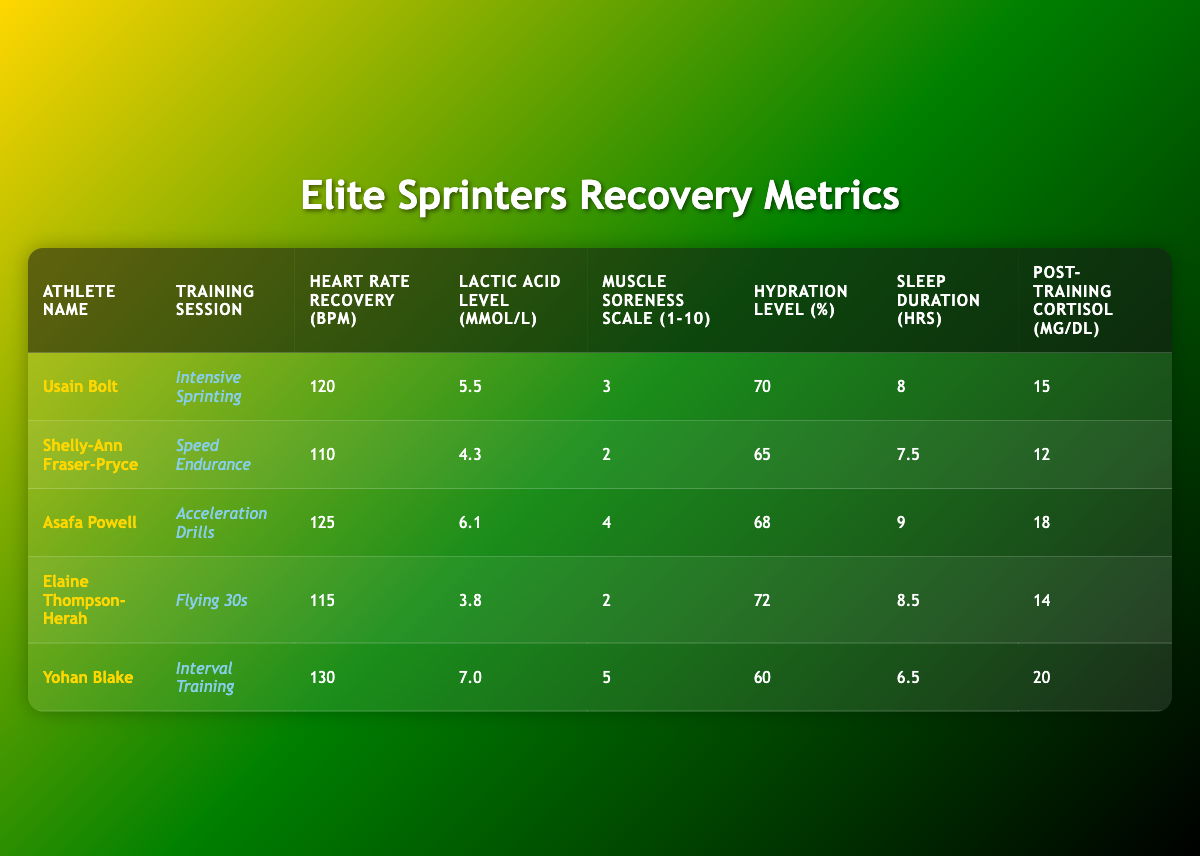What is Usain Bolt's lactic acid level? Usain Bolt's lactic acid level is directly listed in the table under his row. The value is 5.5 mmol/L.
Answer: 5.5 mmol/L What training session did Shelly-Ann Fraser-Pryce participate in? The table lists the training session for each athlete. For Shelly-Ann Fraser-Pryce, the training session is "Speed Endurance."
Answer: Speed Endurance Who has the highest heart rate recovery value? To find the highest heart rate recovery, we must compare the values from each athlete's row. Yohan Blake has the highest heart rate recovery at 130 bpm.
Answer: Yohan Blake What is the average sleep duration of all athletes? The sleep durations are: 8, 7.5, 9, 8.5, and 6.5 hours. Adding these gives a total of 39.5 hours. Dividing by the number of athletes, 5, gives an average of 39.5/5 = 7.9 hours.
Answer: 7.9 hours Did Elaine Thompson-Herah have a hydration level above 70%? Looking at Elaine Thompson-Herah's row, her hydration level is 72%. Since 72 is greater than 70, the answer is yes.
Answer: Yes What is the difference between the highest and lowest muscle soreness scale? The highest muscle soreness scale is 5 (Yohan Blake), and the lowest is 2 (Shelly-Ann Fraser-Pryce and Elaine Thompson-Herah). The difference is 5 - 2 = 3.
Answer: 3 Which athlete had the lowest post-training cortisol level? By checking the post-training cortisol values for each athlete, Shelly-Ann Fraser-Pryce has the lowest at 12 μg/dL compared to others.
Answer: Shelly-Ann Fraser-Pryce Which athlete trained with the "Interval Training" session? The athlete who participated in "Interval Training" is clearly listed in the table as Yohan Blake.
Answer: Yohan Blake What percentage of hydration did Asafa Powell have compared to the other athletes? Asafa Powell's hydration level is 68%. Comparing all hydration levels, he has greater hydration than Shelly-Ann Fraser-Pryce (65%) and Yohan Blake (60%), but lower than Usain Bolt (70%) and Elaine Thompson-Herah (72%).
Answer: Moderate (68%) 